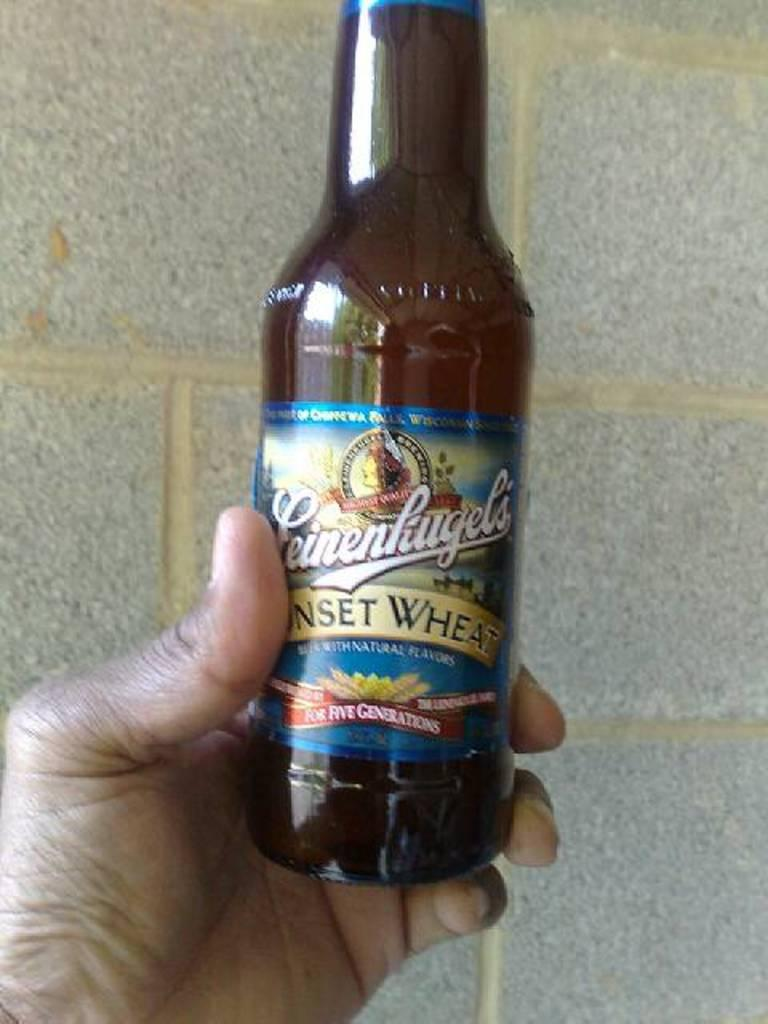Provide a one-sentence caption for the provided image. A brown beer bottle with a label that reads Sunset Wheat. 